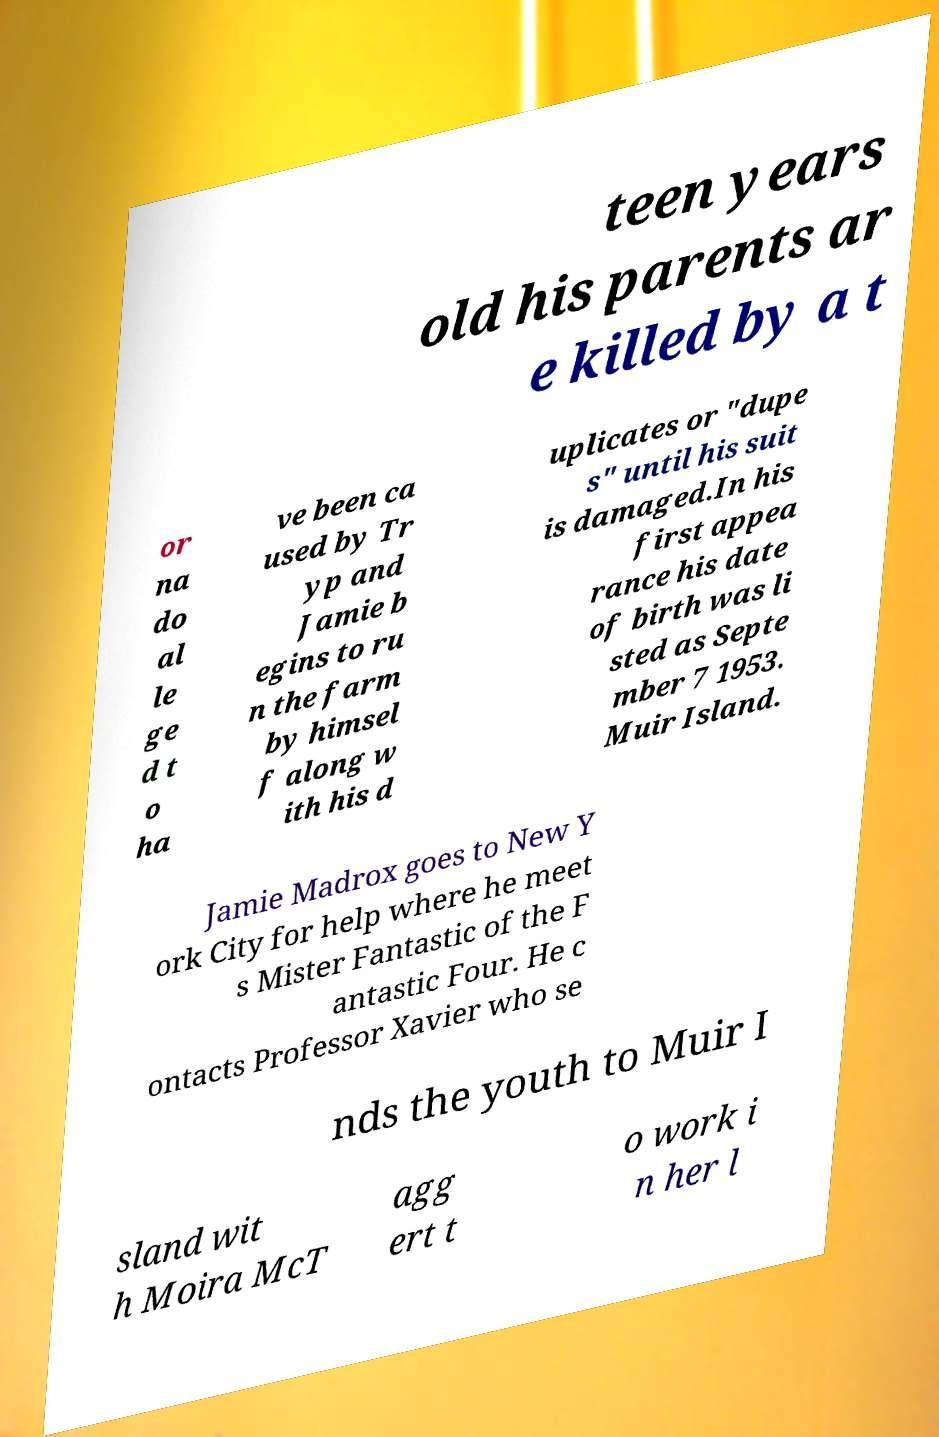What messages or text are displayed in this image? I need them in a readable, typed format. teen years old his parents ar e killed by a t or na do al le ge d t o ha ve been ca used by Tr yp and Jamie b egins to ru n the farm by himsel f along w ith his d uplicates or "dupe s" until his suit is damaged.In his first appea rance his date of birth was li sted as Septe mber 7 1953. Muir Island. Jamie Madrox goes to New Y ork City for help where he meet s Mister Fantastic of the F antastic Four. He c ontacts Professor Xavier who se nds the youth to Muir I sland wit h Moira McT agg ert t o work i n her l 